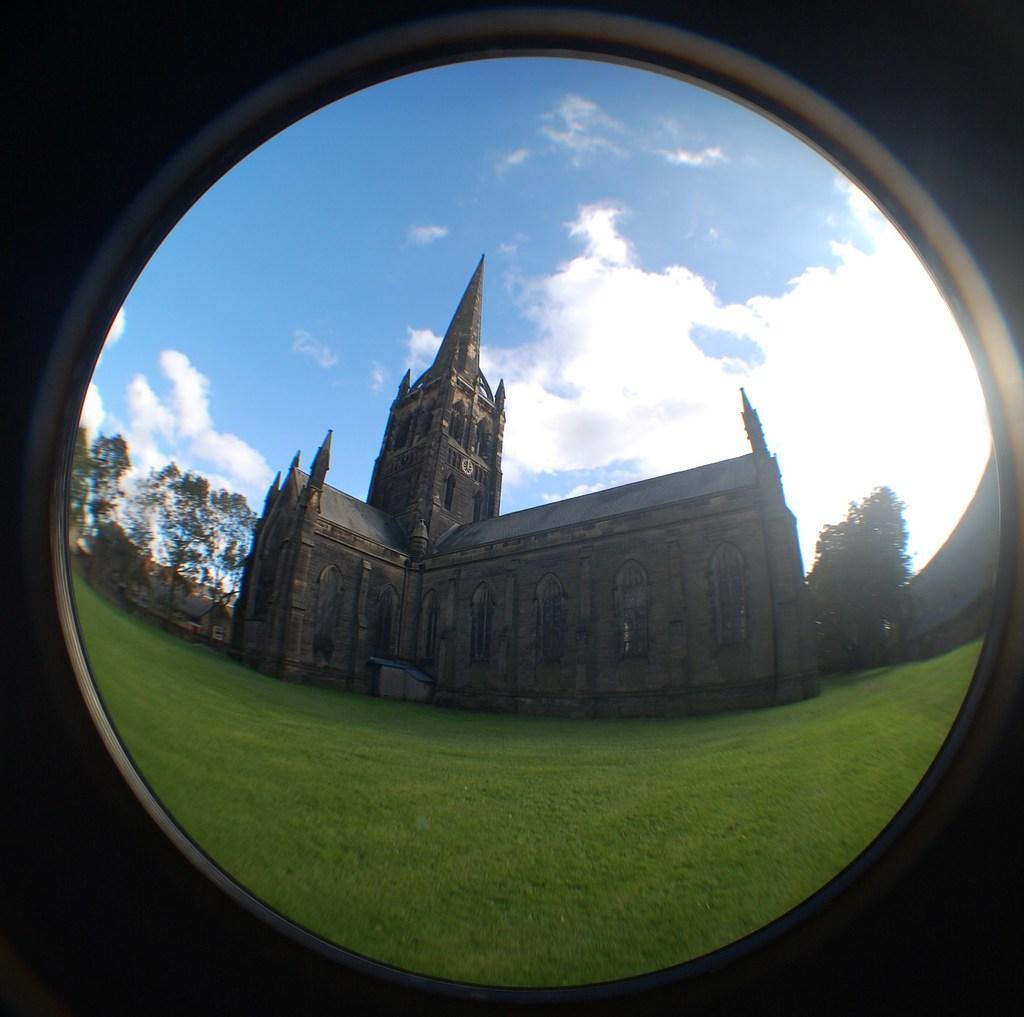Please provide a concise description of this image. In this picture we can see a glass. Through glass we can see sky with clouds, a tower , green grass near to it and beside to the tower we can see trees. 